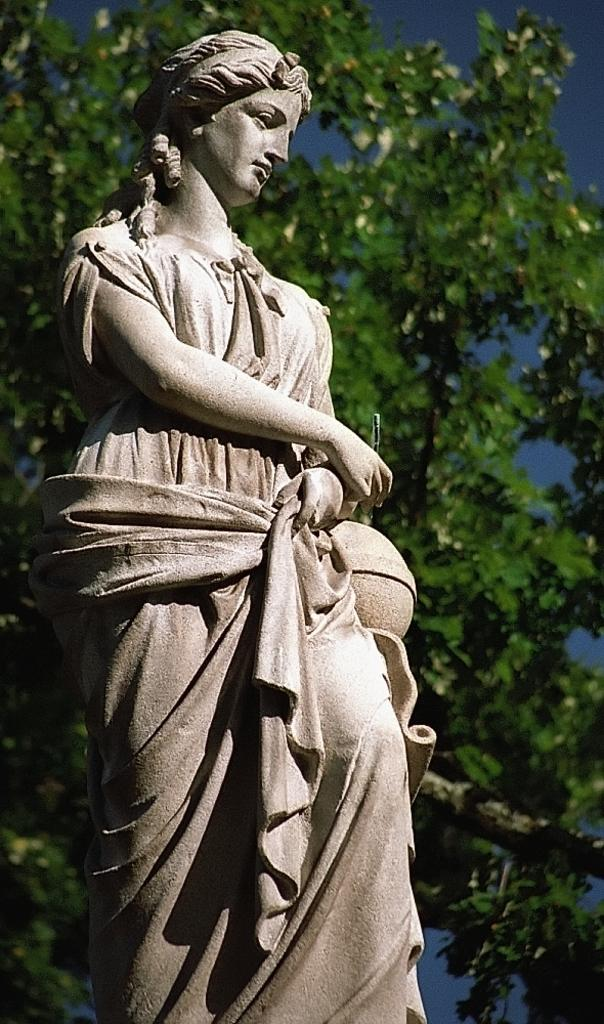What is the main subject in the image? There is a statue of a lady in the image. What can be seen in the background of the image? There is a tree and the sky visible in the background of the image. What type of haircut does the statue of the lady have in the image? The statue of the lady does not have a haircut, as it is a statue and not a living person. Can you see any mist in the image? There is no mention of mist in the image, and it is not visible in the provided facts. 